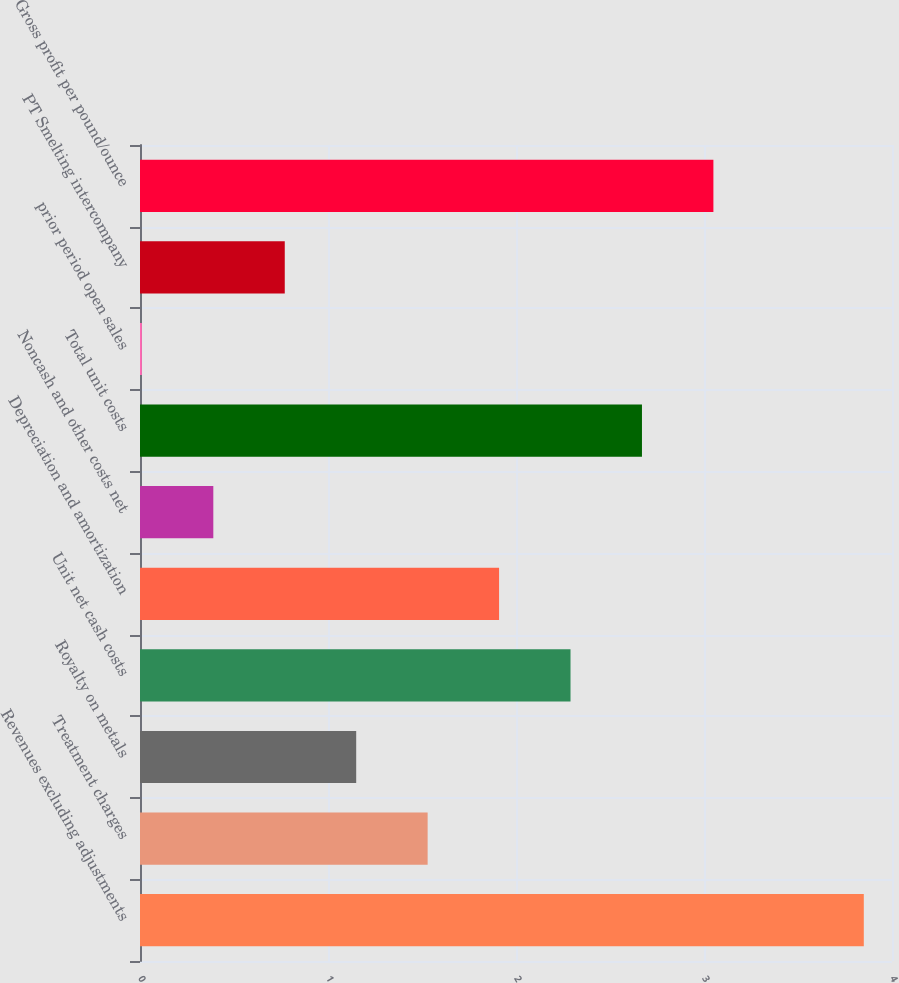<chart> <loc_0><loc_0><loc_500><loc_500><bar_chart><fcel>Revenues excluding adjustments<fcel>Treatment charges<fcel>Royalty on metals<fcel>Unit net cash costs<fcel>Depreciation and amortization<fcel>Noncash and other costs net<fcel>Total unit costs<fcel>prior period open sales<fcel>PT Smelting intercompany<fcel>Gross profit per pound/ounce<nl><fcel>3.85<fcel>1.53<fcel>1.15<fcel>2.29<fcel>1.91<fcel>0.39<fcel>2.67<fcel>0.01<fcel>0.77<fcel>3.05<nl></chart> 